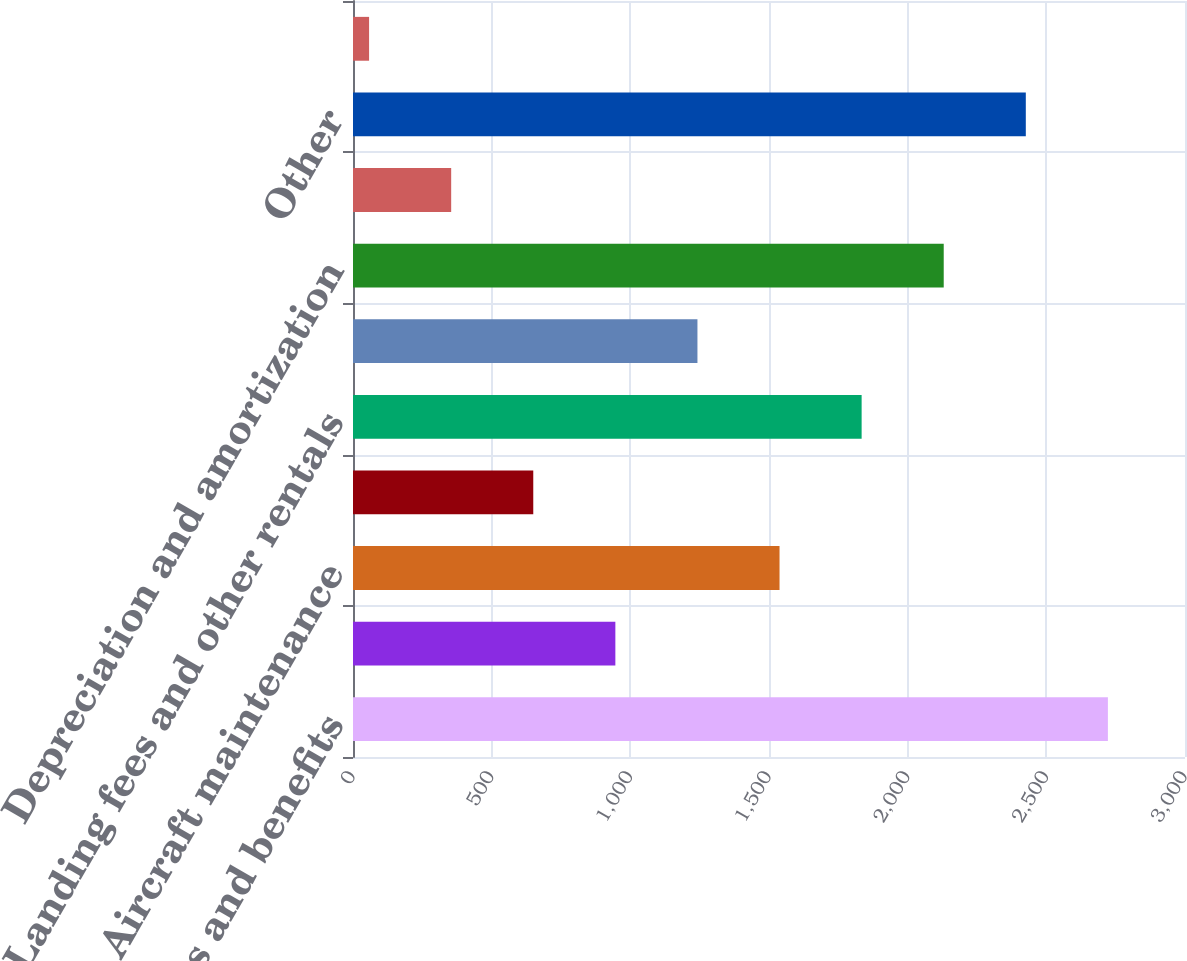Convert chart. <chart><loc_0><loc_0><loc_500><loc_500><bar_chart><fcel>Wages and benefits<fcel>Variable incentive pay<fcel>Aircraft maintenance<fcel>Aircraft rent<fcel>Landing fees and other rentals<fcel>Selling expenses<fcel>Depreciation and amortization<fcel>Food and beverage service<fcel>Other<fcel>Third-party regional carrier<nl><fcel>2722<fcel>946<fcel>1538<fcel>650<fcel>1834<fcel>1242<fcel>2130<fcel>354<fcel>2426<fcel>58<nl></chart> 